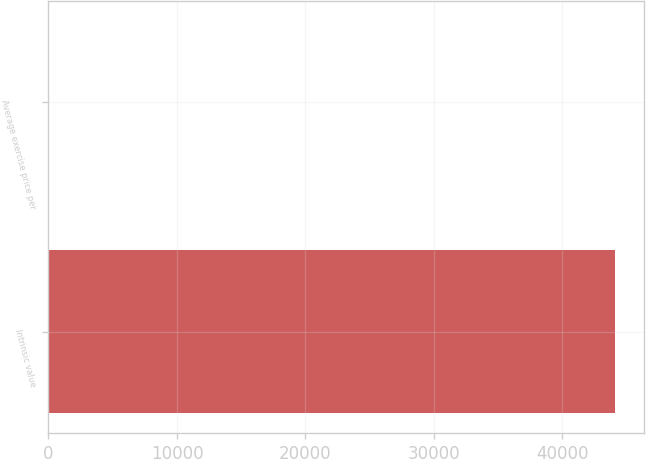<chart> <loc_0><loc_0><loc_500><loc_500><bar_chart><fcel>Intrinsic value<fcel>Average exercise price per<nl><fcel>44104<fcel>26.06<nl></chart> 